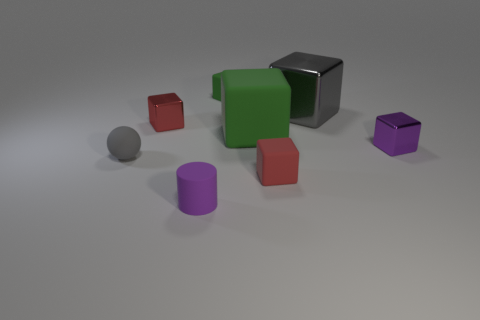Subtract 4 cubes. How many cubes are left? 2 Subtract all small purple cubes. How many cubes are left? 5 Add 1 large cyan shiny cylinders. How many objects exist? 9 Subtract all purple blocks. How many blocks are left? 5 Subtract all gray blocks. Subtract all brown cylinders. How many blocks are left? 5 Subtract all blocks. How many objects are left? 2 Add 6 tiny gray spheres. How many tiny gray spheres exist? 7 Subtract 0 blue blocks. How many objects are left? 8 Subtract all gray shiny things. Subtract all small red rubber objects. How many objects are left? 6 Add 2 gray metal blocks. How many gray metal blocks are left? 3 